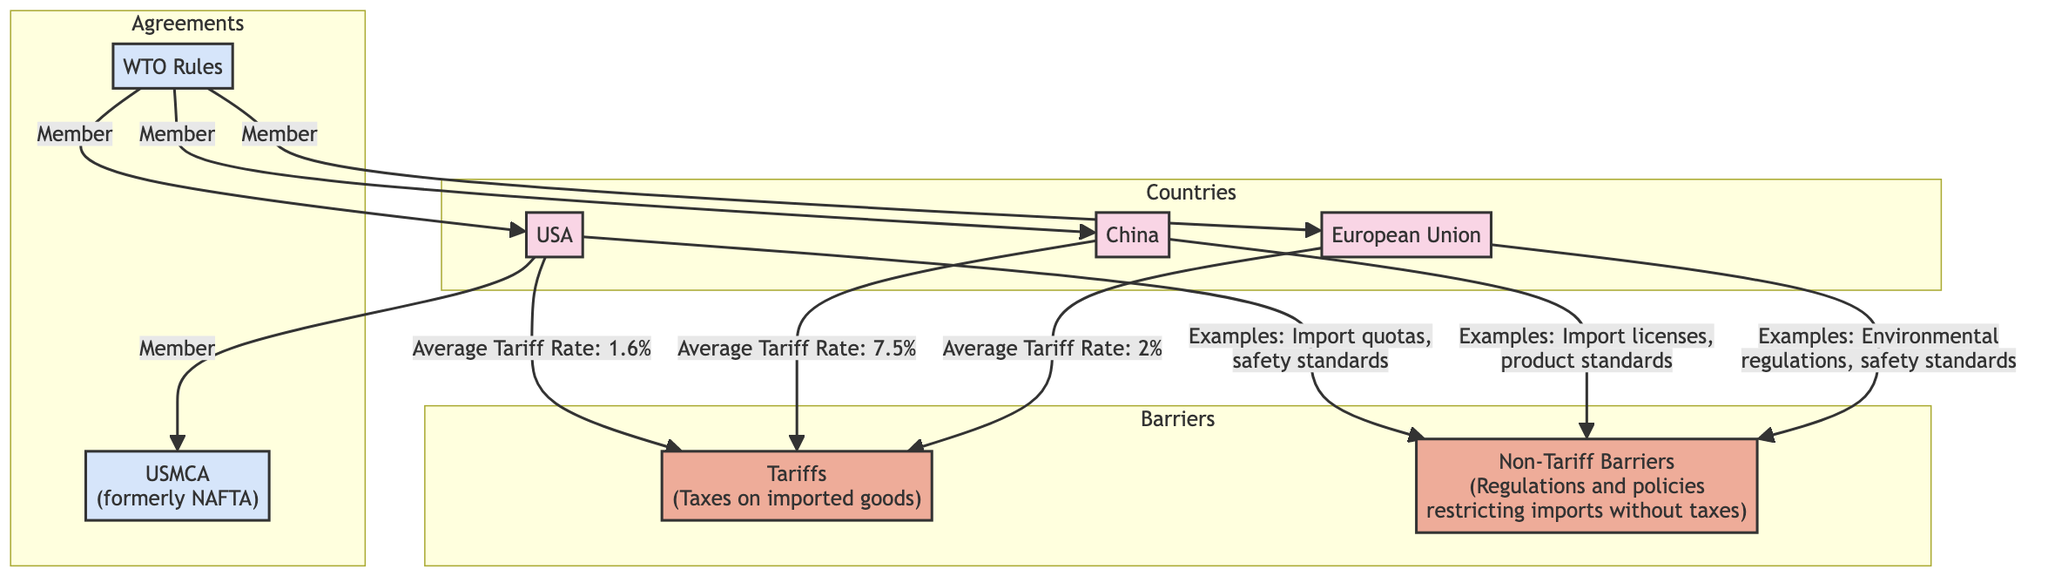What is the average tariff rate for the USA? The diagram indicates that the average tariff rate for the USA is specified directly next to the USA node, which is stated as 1.6%.
Answer: 1.6% What type of barrier is represented by import quotas? The diagram categorizes import quotas under the non-tariff barriers section, which includes various regulations and policies that restrict imports without imposing taxes.
Answer: Non-Tariff Barrier Which country has the highest average tariff rate? By comparing the tariff rates shown in the diagram, China is highlighted with an average tariff rate of 7.5%, which is higher than the USA and EU rates.
Answer: China What are the examples of non-tariff barriers in the EU? The diagram outlines that the examples of non-tariff barriers in the EU include environmental regulations and safety standards, directly listed next to the EU node.
Answer: Environmental regulations, safety standards Which countries are members of WTO rules? The diagram explicitly lists the countries that are members of WTO Rules, which includes the USA, China, and the EU.
Answer: USA, China, EU What is the relationship between the USA and NAFTA? The diagram indicates that the USA is connected to the NAFTA node with a labeled relationship stating "Member," which shows the USA's role in that trade agreement.
Answer: Member Which barriers are identified in the diagram? The diagram clearly defines two types of barriers: tariffs and non-tariff barriers, represented in the Barriers section of the diagram.
Answer: Tariffs, Non-Tariff Barriers What does the non-tariff barriers section include for China? The diagram mentions that the examples for non-tariff barriers in China are import licenses and product standards, which are directly linked to the China node.
Answer: Import licenses, product standards How many countries are analyzed in the diagram? The diagram illustrates three countries: USA, China, and European Union, which can be counted from the Countries section.
Answer: 3 